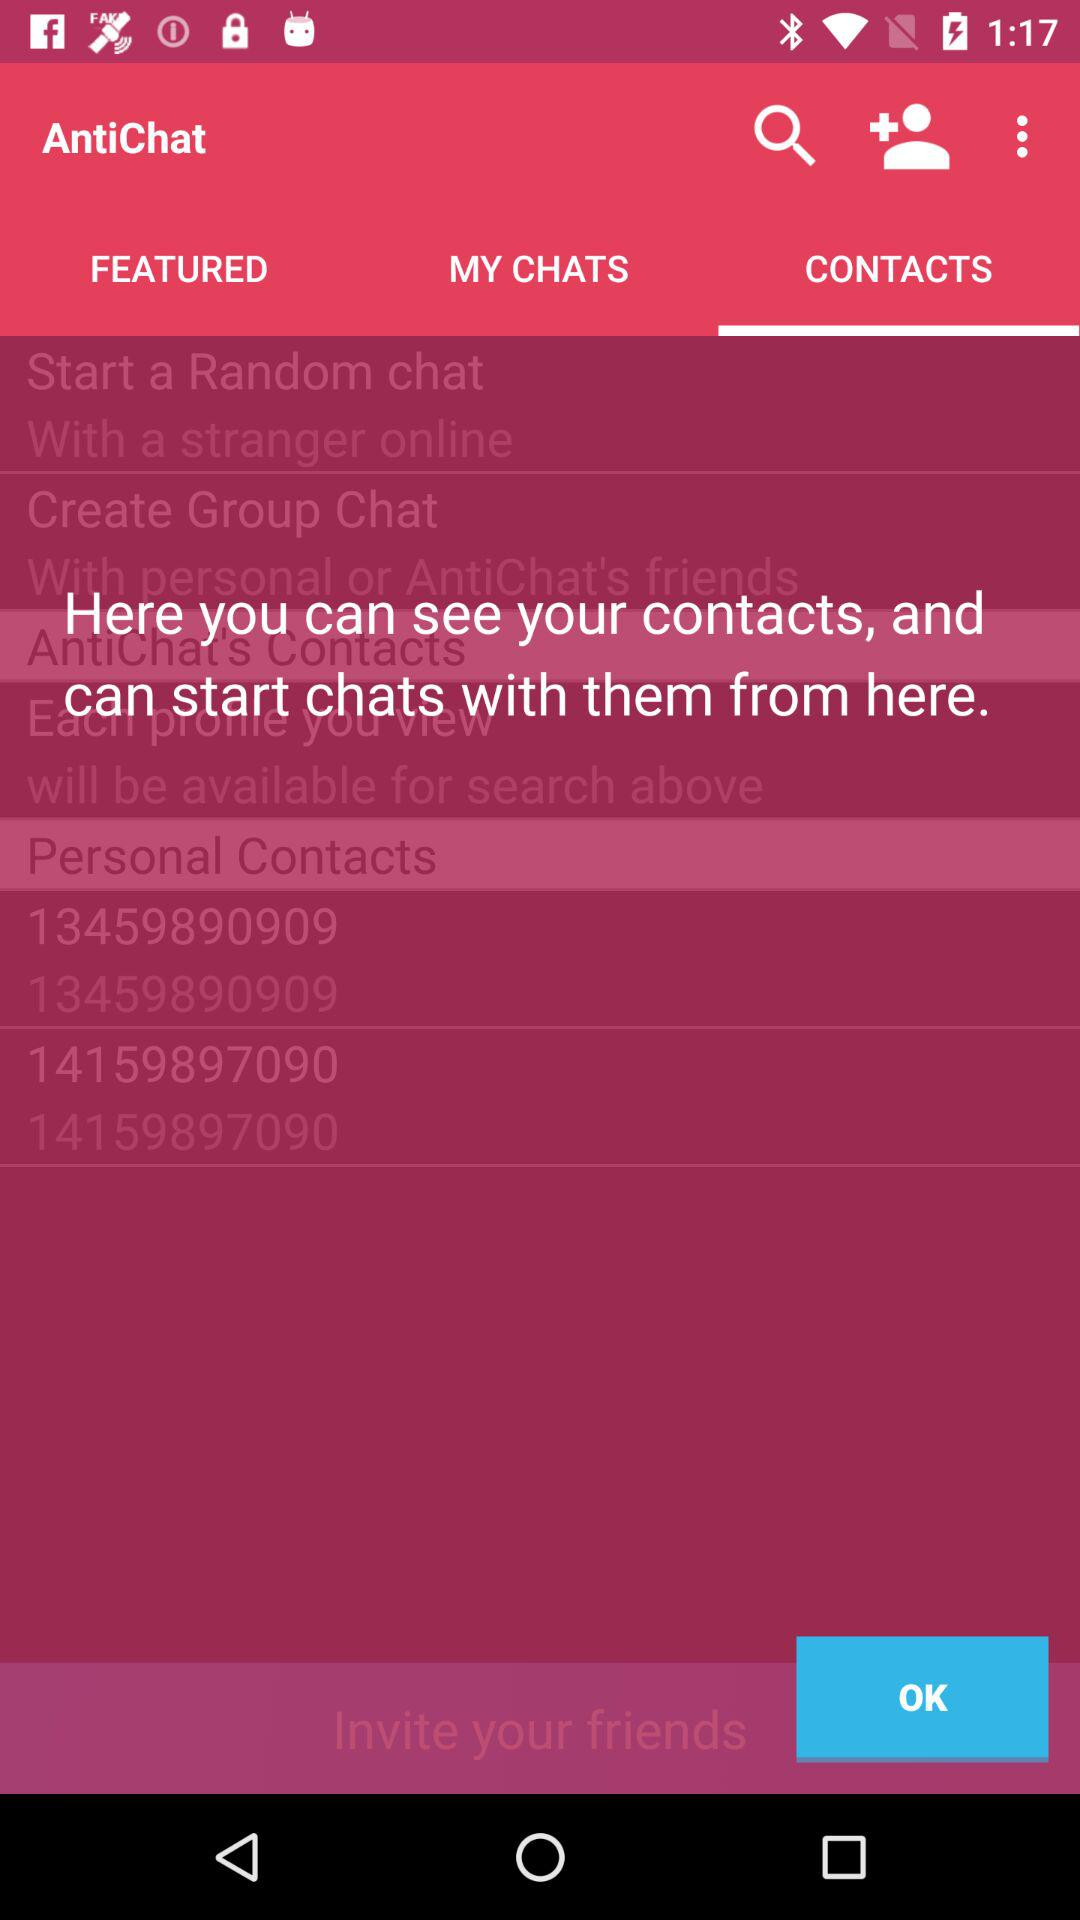Which tab is selected? The selected tab is "CONTACTS". 